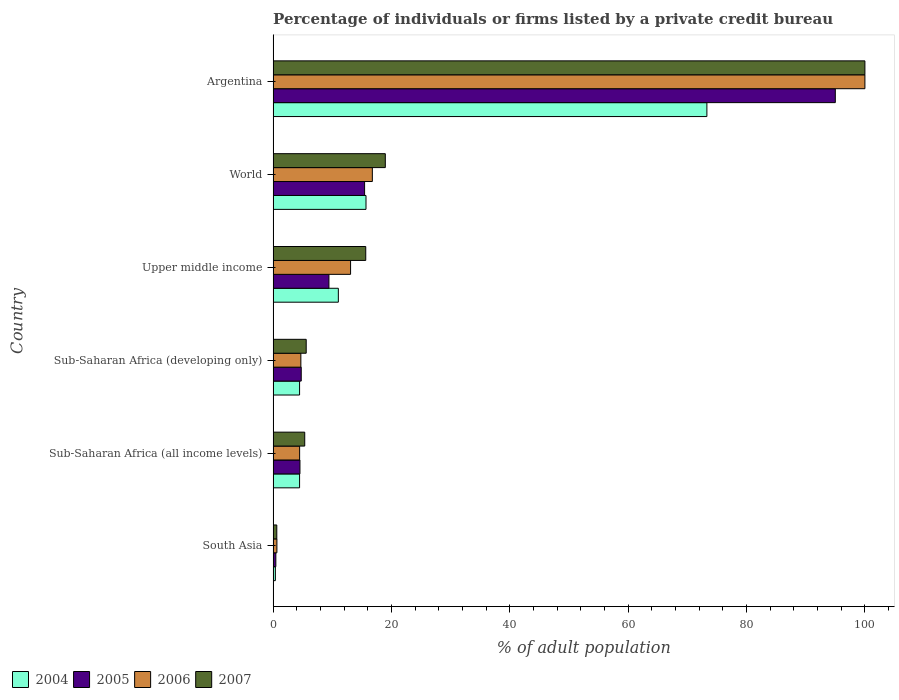How many different coloured bars are there?
Your response must be concise. 4. Are the number of bars per tick equal to the number of legend labels?
Make the answer very short. Yes. How many bars are there on the 5th tick from the bottom?
Provide a succinct answer. 4. What is the label of the 1st group of bars from the top?
Make the answer very short. Argentina. Across all countries, what is the minimum percentage of population listed by a private credit bureau in 2005?
Give a very brief answer. 0.46. In which country was the percentage of population listed by a private credit bureau in 2007 minimum?
Your response must be concise. South Asia. What is the total percentage of population listed by a private credit bureau in 2004 in the graph?
Make the answer very short. 109.34. What is the difference between the percentage of population listed by a private credit bureau in 2006 in Sub-Saharan Africa (developing only) and that in Upper middle income?
Offer a very short reply. -8.4. What is the difference between the percentage of population listed by a private credit bureau in 2007 in Sub-Saharan Africa (all income levels) and the percentage of population listed by a private credit bureau in 2005 in Upper middle income?
Give a very brief answer. -4.09. What is the average percentage of population listed by a private credit bureau in 2006 per country?
Offer a terse response. 23.28. What is the difference between the percentage of population listed by a private credit bureau in 2007 and percentage of population listed by a private credit bureau in 2005 in Sub-Saharan Africa (developing only)?
Make the answer very short. 0.84. In how many countries, is the percentage of population listed by a private credit bureau in 2005 greater than 100 %?
Your response must be concise. 0. What is the ratio of the percentage of population listed by a private credit bureau in 2004 in Sub-Saharan Africa (developing only) to that in Upper middle income?
Make the answer very short. 0.41. Is the percentage of population listed by a private credit bureau in 2007 in Upper middle income less than that in World?
Keep it short and to the point. Yes. Is the difference between the percentage of population listed by a private credit bureau in 2007 in Sub-Saharan Africa (all income levels) and Sub-Saharan Africa (developing only) greater than the difference between the percentage of population listed by a private credit bureau in 2005 in Sub-Saharan Africa (all income levels) and Sub-Saharan Africa (developing only)?
Your answer should be very brief. No. What is the difference between the highest and the second highest percentage of population listed by a private credit bureau in 2004?
Offer a terse response. 57.6. What is the difference between the highest and the lowest percentage of population listed by a private credit bureau in 2007?
Keep it short and to the point. 99.38. In how many countries, is the percentage of population listed by a private credit bureau in 2004 greater than the average percentage of population listed by a private credit bureau in 2004 taken over all countries?
Keep it short and to the point. 1. Is the sum of the percentage of population listed by a private credit bureau in 2007 in South Asia and Sub-Saharan Africa (developing only) greater than the maximum percentage of population listed by a private credit bureau in 2006 across all countries?
Your answer should be compact. No. Is it the case that in every country, the sum of the percentage of population listed by a private credit bureau in 2007 and percentage of population listed by a private credit bureau in 2006 is greater than the sum of percentage of population listed by a private credit bureau in 2004 and percentage of population listed by a private credit bureau in 2005?
Your answer should be very brief. No. What does the 4th bar from the bottom in Sub-Saharan Africa (all income levels) represents?
Your answer should be compact. 2007. Is it the case that in every country, the sum of the percentage of population listed by a private credit bureau in 2007 and percentage of population listed by a private credit bureau in 2006 is greater than the percentage of population listed by a private credit bureau in 2004?
Your answer should be very brief. Yes. How many bars are there?
Your answer should be compact. 24. What is the difference between two consecutive major ticks on the X-axis?
Your answer should be very brief. 20. Does the graph contain grids?
Give a very brief answer. No. Where does the legend appear in the graph?
Your response must be concise. Bottom left. How are the legend labels stacked?
Provide a short and direct response. Horizontal. What is the title of the graph?
Make the answer very short. Percentage of individuals or firms listed by a private credit bureau. Does "1969" appear as one of the legend labels in the graph?
Provide a succinct answer. No. What is the label or title of the X-axis?
Ensure brevity in your answer.  % of adult population. What is the label or title of the Y-axis?
Your answer should be very brief. Country. What is the % of adult population in 2004 in South Asia?
Make the answer very short. 0.38. What is the % of adult population in 2005 in South Asia?
Offer a terse response. 0.46. What is the % of adult population of 2006 in South Asia?
Provide a short and direct response. 0.64. What is the % of adult population of 2007 in South Asia?
Your response must be concise. 0.62. What is the % of adult population of 2004 in Sub-Saharan Africa (all income levels)?
Provide a succinct answer. 4.47. What is the % of adult population of 2005 in Sub-Saharan Africa (all income levels)?
Provide a short and direct response. 4.53. What is the % of adult population in 2006 in Sub-Saharan Africa (all income levels)?
Keep it short and to the point. 4.48. What is the % of adult population in 2007 in Sub-Saharan Africa (all income levels)?
Keep it short and to the point. 5.34. What is the % of adult population of 2004 in Sub-Saharan Africa (developing only)?
Your answer should be compact. 4.47. What is the % of adult population of 2005 in Sub-Saharan Africa (developing only)?
Provide a succinct answer. 4.75. What is the % of adult population in 2006 in Sub-Saharan Africa (developing only)?
Ensure brevity in your answer.  4.69. What is the % of adult population in 2007 in Sub-Saharan Africa (developing only)?
Offer a very short reply. 5.59. What is the % of adult population in 2004 in Upper middle income?
Offer a very short reply. 11.02. What is the % of adult population of 2005 in Upper middle income?
Give a very brief answer. 9.43. What is the % of adult population in 2006 in Upper middle income?
Ensure brevity in your answer.  13.09. What is the % of adult population of 2007 in Upper middle income?
Provide a succinct answer. 15.65. What is the % of adult population of 2004 in World?
Your answer should be compact. 15.7. What is the % of adult population in 2005 in World?
Your response must be concise. 15.46. What is the % of adult population in 2006 in World?
Provide a short and direct response. 16.77. What is the % of adult population of 2007 in World?
Your answer should be very brief. 18.96. What is the % of adult population in 2004 in Argentina?
Provide a succinct answer. 73.3. Across all countries, what is the maximum % of adult population in 2004?
Your answer should be compact. 73.3. Across all countries, what is the maximum % of adult population of 2005?
Ensure brevity in your answer.  95. Across all countries, what is the minimum % of adult population in 2004?
Give a very brief answer. 0.38. Across all countries, what is the minimum % of adult population of 2005?
Keep it short and to the point. 0.46. Across all countries, what is the minimum % of adult population in 2006?
Give a very brief answer. 0.64. Across all countries, what is the minimum % of adult population of 2007?
Your answer should be compact. 0.62. What is the total % of adult population of 2004 in the graph?
Provide a succinct answer. 109.34. What is the total % of adult population in 2005 in the graph?
Ensure brevity in your answer.  129.63. What is the total % of adult population of 2006 in the graph?
Provide a succinct answer. 139.66. What is the total % of adult population in 2007 in the graph?
Make the answer very short. 146.17. What is the difference between the % of adult population of 2004 in South Asia and that in Sub-Saharan Africa (all income levels)?
Make the answer very short. -4.09. What is the difference between the % of adult population in 2005 in South Asia and that in Sub-Saharan Africa (all income levels)?
Your answer should be very brief. -4.07. What is the difference between the % of adult population of 2006 in South Asia and that in Sub-Saharan Africa (all income levels)?
Give a very brief answer. -3.84. What is the difference between the % of adult population in 2007 in South Asia and that in Sub-Saharan Africa (all income levels)?
Your answer should be compact. -4.72. What is the difference between the % of adult population of 2004 in South Asia and that in Sub-Saharan Africa (developing only)?
Offer a terse response. -4.09. What is the difference between the % of adult population in 2005 in South Asia and that in Sub-Saharan Africa (developing only)?
Keep it short and to the point. -4.29. What is the difference between the % of adult population in 2006 in South Asia and that in Sub-Saharan Africa (developing only)?
Ensure brevity in your answer.  -4.05. What is the difference between the % of adult population of 2007 in South Asia and that in Sub-Saharan Africa (developing only)?
Give a very brief answer. -4.97. What is the difference between the % of adult population of 2004 in South Asia and that in Upper middle income?
Make the answer very short. -10.64. What is the difference between the % of adult population of 2005 in South Asia and that in Upper middle income?
Keep it short and to the point. -8.97. What is the difference between the % of adult population in 2006 in South Asia and that in Upper middle income?
Ensure brevity in your answer.  -12.45. What is the difference between the % of adult population in 2007 in South Asia and that in Upper middle income?
Offer a very short reply. -15.03. What is the difference between the % of adult population in 2004 in South Asia and that in World?
Your response must be concise. -15.32. What is the difference between the % of adult population in 2005 in South Asia and that in World?
Your answer should be very brief. -15. What is the difference between the % of adult population of 2006 in South Asia and that in World?
Keep it short and to the point. -16.13. What is the difference between the % of adult population of 2007 in South Asia and that in World?
Keep it short and to the point. -18.34. What is the difference between the % of adult population in 2004 in South Asia and that in Argentina?
Offer a terse response. -72.92. What is the difference between the % of adult population in 2005 in South Asia and that in Argentina?
Offer a very short reply. -94.54. What is the difference between the % of adult population of 2006 in South Asia and that in Argentina?
Your answer should be compact. -99.36. What is the difference between the % of adult population of 2007 in South Asia and that in Argentina?
Your answer should be compact. -99.38. What is the difference between the % of adult population of 2005 in Sub-Saharan Africa (all income levels) and that in Sub-Saharan Africa (developing only)?
Offer a terse response. -0.22. What is the difference between the % of adult population of 2006 in Sub-Saharan Africa (all income levels) and that in Sub-Saharan Africa (developing only)?
Your answer should be very brief. -0.21. What is the difference between the % of adult population of 2007 in Sub-Saharan Africa (all income levels) and that in Sub-Saharan Africa (developing only)?
Give a very brief answer. -0.25. What is the difference between the % of adult population in 2004 in Sub-Saharan Africa (all income levels) and that in Upper middle income?
Your response must be concise. -6.55. What is the difference between the % of adult population of 2005 in Sub-Saharan Africa (all income levels) and that in Upper middle income?
Your response must be concise. -4.9. What is the difference between the % of adult population of 2006 in Sub-Saharan Africa (all income levels) and that in Upper middle income?
Keep it short and to the point. -8.61. What is the difference between the % of adult population in 2007 in Sub-Saharan Africa (all income levels) and that in Upper middle income?
Give a very brief answer. -10.31. What is the difference between the % of adult population in 2004 in Sub-Saharan Africa (all income levels) and that in World?
Provide a short and direct response. -11.23. What is the difference between the % of adult population in 2005 in Sub-Saharan Africa (all income levels) and that in World?
Provide a succinct answer. -10.92. What is the difference between the % of adult population in 2006 in Sub-Saharan Africa (all income levels) and that in World?
Offer a terse response. -12.29. What is the difference between the % of adult population in 2007 in Sub-Saharan Africa (all income levels) and that in World?
Keep it short and to the point. -13.62. What is the difference between the % of adult population in 2004 in Sub-Saharan Africa (all income levels) and that in Argentina?
Offer a terse response. -68.83. What is the difference between the % of adult population in 2005 in Sub-Saharan Africa (all income levels) and that in Argentina?
Provide a succinct answer. -90.47. What is the difference between the % of adult population in 2006 in Sub-Saharan Africa (all income levels) and that in Argentina?
Give a very brief answer. -95.52. What is the difference between the % of adult population in 2007 in Sub-Saharan Africa (all income levels) and that in Argentina?
Provide a succinct answer. -94.66. What is the difference between the % of adult population of 2004 in Sub-Saharan Africa (developing only) and that in Upper middle income?
Give a very brief answer. -6.55. What is the difference between the % of adult population in 2005 in Sub-Saharan Africa (developing only) and that in Upper middle income?
Offer a very short reply. -4.68. What is the difference between the % of adult population of 2006 in Sub-Saharan Africa (developing only) and that in Upper middle income?
Your answer should be very brief. -8.4. What is the difference between the % of adult population in 2007 in Sub-Saharan Africa (developing only) and that in Upper middle income?
Offer a very short reply. -10.06. What is the difference between the % of adult population of 2004 in Sub-Saharan Africa (developing only) and that in World?
Your answer should be very brief. -11.23. What is the difference between the % of adult population of 2005 in Sub-Saharan Africa (developing only) and that in World?
Provide a succinct answer. -10.71. What is the difference between the % of adult population of 2006 in Sub-Saharan Africa (developing only) and that in World?
Give a very brief answer. -12.08. What is the difference between the % of adult population of 2007 in Sub-Saharan Africa (developing only) and that in World?
Your response must be concise. -13.37. What is the difference between the % of adult population in 2004 in Sub-Saharan Africa (developing only) and that in Argentina?
Make the answer very short. -68.83. What is the difference between the % of adult population in 2005 in Sub-Saharan Africa (developing only) and that in Argentina?
Keep it short and to the point. -90.25. What is the difference between the % of adult population in 2006 in Sub-Saharan Africa (developing only) and that in Argentina?
Ensure brevity in your answer.  -95.31. What is the difference between the % of adult population of 2007 in Sub-Saharan Africa (developing only) and that in Argentina?
Your answer should be very brief. -94.41. What is the difference between the % of adult population of 2004 in Upper middle income and that in World?
Offer a very short reply. -4.67. What is the difference between the % of adult population in 2005 in Upper middle income and that in World?
Ensure brevity in your answer.  -6.02. What is the difference between the % of adult population in 2006 in Upper middle income and that in World?
Your answer should be very brief. -3.68. What is the difference between the % of adult population of 2007 in Upper middle income and that in World?
Provide a succinct answer. -3.31. What is the difference between the % of adult population of 2004 in Upper middle income and that in Argentina?
Give a very brief answer. -62.28. What is the difference between the % of adult population of 2005 in Upper middle income and that in Argentina?
Keep it short and to the point. -85.57. What is the difference between the % of adult population in 2006 in Upper middle income and that in Argentina?
Give a very brief answer. -86.91. What is the difference between the % of adult population in 2007 in Upper middle income and that in Argentina?
Your answer should be compact. -84.35. What is the difference between the % of adult population of 2004 in World and that in Argentina?
Offer a terse response. -57.6. What is the difference between the % of adult population of 2005 in World and that in Argentina?
Make the answer very short. -79.54. What is the difference between the % of adult population in 2006 in World and that in Argentina?
Your answer should be very brief. -83.23. What is the difference between the % of adult population in 2007 in World and that in Argentina?
Give a very brief answer. -81.04. What is the difference between the % of adult population in 2004 in South Asia and the % of adult population in 2005 in Sub-Saharan Africa (all income levels)?
Your answer should be compact. -4.15. What is the difference between the % of adult population in 2004 in South Asia and the % of adult population in 2006 in Sub-Saharan Africa (all income levels)?
Give a very brief answer. -4.1. What is the difference between the % of adult population of 2004 in South Asia and the % of adult population of 2007 in Sub-Saharan Africa (all income levels)?
Provide a short and direct response. -4.96. What is the difference between the % of adult population of 2005 in South Asia and the % of adult population of 2006 in Sub-Saharan Africa (all income levels)?
Your response must be concise. -4.02. What is the difference between the % of adult population of 2005 in South Asia and the % of adult population of 2007 in Sub-Saharan Africa (all income levels)?
Keep it short and to the point. -4.88. What is the difference between the % of adult population in 2006 in South Asia and the % of adult population in 2007 in Sub-Saharan Africa (all income levels)?
Ensure brevity in your answer.  -4.7. What is the difference between the % of adult population of 2004 in South Asia and the % of adult population of 2005 in Sub-Saharan Africa (developing only)?
Provide a succinct answer. -4.37. What is the difference between the % of adult population in 2004 in South Asia and the % of adult population in 2006 in Sub-Saharan Africa (developing only)?
Offer a very short reply. -4.31. What is the difference between the % of adult population in 2004 in South Asia and the % of adult population in 2007 in Sub-Saharan Africa (developing only)?
Offer a terse response. -5.21. What is the difference between the % of adult population in 2005 in South Asia and the % of adult population in 2006 in Sub-Saharan Africa (developing only)?
Make the answer very short. -4.23. What is the difference between the % of adult population in 2005 in South Asia and the % of adult population in 2007 in Sub-Saharan Africa (developing only)?
Keep it short and to the point. -5.13. What is the difference between the % of adult population of 2006 in South Asia and the % of adult population of 2007 in Sub-Saharan Africa (developing only)?
Provide a succinct answer. -4.95. What is the difference between the % of adult population in 2004 in South Asia and the % of adult population in 2005 in Upper middle income?
Give a very brief answer. -9.05. What is the difference between the % of adult population of 2004 in South Asia and the % of adult population of 2006 in Upper middle income?
Keep it short and to the point. -12.71. What is the difference between the % of adult population in 2004 in South Asia and the % of adult population in 2007 in Upper middle income?
Offer a very short reply. -15.27. What is the difference between the % of adult population of 2005 in South Asia and the % of adult population of 2006 in Upper middle income?
Keep it short and to the point. -12.63. What is the difference between the % of adult population of 2005 in South Asia and the % of adult population of 2007 in Upper middle income?
Provide a succinct answer. -15.19. What is the difference between the % of adult population of 2006 in South Asia and the % of adult population of 2007 in Upper middle income?
Give a very brief answer. -15.01. What is the difference between the % of adult population in 2004 in South Asia and the % of adult population in 2005 in World?
Offer a very short reply. -15.08. What is the difference between the % of adult population in 2004 in South Asia and the % of adult population in 2006 in World?
Make the answer very short. -16.39. What is the difference between the % of adult population in 2004 in South Asia and the % of adult population in 2007 in World?
Your response must be concise. -18.58. What is the difference between the % of adult population of 2005 in South Asia and the % of adult population of 2006 in World?
Offer a very short reply. -16.31. What is the difference between the % of adult population in 2005 in South Asia and the % of adult population in 2007 in World?
Your answer should be very brief. -18.5. What is the difference between the % of adult population of 2006 in South Asia and the % of adult population of 2007 in World?
Ensure brevity in your answer.  -18.32. What is the difference between the % of adult population in 2004 in South Asia and the % of adult population in 2005 in Argentina?
Your answer should be compact. -94.62. What is the difference between the % of adult population of 2004 in South Asia and the % of adult population of 2006 in Argentina?
Make the answer very short. -99.62. What is the difference between the % of adult population in 2004 in South Asia and the % of adult population in 2007 in Argentina?
Your response must be concise. -99.62. What is the difference between the % of adult population in 2005 in South Asia and the % of adult population in 2006 in Argentina?
Give a very brief answer. -99.54. What is the difference between the % of adult population in 2005 in South Asia and the % of adult population in 2007 in Argentina?
Offer a terse response. -99.54. What is the difference between the % of adult population in 2006 in South Asia and the % of adult population in 2007 in Argentina?
Your answer should be very brief. -99.36. What is the difference between the % of adult population of 2004 in Sub-Saharan Africa (all income levels) and the % of adult population of 2005 in Sub-Saharan Africa (developing only)?
Provide a succinct answer. -0.28. What is the difference between the % of adult population of 2004 in Sub-Saharan Africa (all income levels) and the % of adult population of 2006 in Sub-Saharan Africa (developing only)?
Your answer should be compact. -0.22. What is the difference between the % of adult population of 2004 in Sub-Saharan Africa (all income levels) and the % of adult population of 2007 in Sub-Saharan Africa (developing only)?
Your answer should be very brief. -1.12. What is the difference between the % of adult population of 2005 in Sub-Saharan Africa (all income levels) and the % of adult population of 2006 in Sub-Saharan Africa (developing only)?
Ensure brevity in your answer.  -0.15. What is the difference between the % of adult population of 2005 in Sub-Saharan Africa (all income levels) and the % of adult population of 2007 in Sub-Saharan Africa (developing only)?
Provide a succinct answer. -1.06. What is the difference between the % of adult population in 2006 in Sub-Saharan Africa (all income levels) and the % of adult population in 2007 in Sub-Saharan Africa (developing only)?
Your response must be concise. -1.11. What is the difference between the % of adult population of 2004 in Sub-Saharan Africa (all income levels) and the % of adult population of 2005 in Upper middle income?
Give a very brief answer. -4.96. What is the difference between the % of adult population in 2004 in Sub-Saharan Africa (all income levels) and the % of adult population in 2006 in Upper middle income?
Your answer should be very brief. -8.62. What is the difference between the % of adult population in 2004 in Sub-Saharan Africa (all income levels) and the % of adult population in 2007 in Upper middle income?
Offer a very short reply. -11.18. What is the difference between the % of adult population in 2005 in Sub-Saharan Africa (all income levels) and the % of adult population in 2006 in Upper middle income?
Your response must be concise. -8.55. What is the difference between the % of adult population in 2005 in Sub-Saharan Africa (all income levels) and the % of adult population in 2007 in Upper middle income?
Provide a succinct answer. -11.12. What is the difference between the % of adult population in 2006 in Sub-Saharan Africa (all income levels) and the % of adult population in 2007 in Upper middle income?
Make the answer very short. -11.18. What is the difference between the % of adult population in 2004 in Sub-Saharan Africa (all income levels) and the % of adult population in 2005 in World?
Your response must be concise. -10.99. What is the difference between the % of adult population of 2004 in Sub-Saharan Africa (all income levels) and the % of adult population of 2006 in World?
Provide a short and direct response. -12.3. What is the difference between the % of adult population in 2004 in Sub-Saharan Africa (all income levels) and the % of adult population in 2007 in World?
Give a very brief answer. -14.49. What is the difference between the % of adult population in 2005 in Sub-Saharan Africa (all income levels) and the % of adult population in 2006 in World?
Keep it short and to the point. -12.23. What is the difference between the % of adult population of 2005 in Sub-Saharan Africa (all income levels) and the % of adult population of 2007 in World?
Your answer should be very brief. -14.43. What is the difference between the % of adult population of 2006 in Sub-Saharan Africa (all income levels) and the % of adult population of 2007 in World?
Give a very brief answer. -14.48. What is the difference between the % of adult population in 2004 in Sub-Saharan Africa (all income levels) and the % of adult population in 2005 in Argentina?
Keep it short and to the point. -90.53. What is the difference between the % of adult population of 2004 in Sub-Saharan Africa (all income levels) and the % of adult population of 2006 in Argentina?
Ensure brevity in your answer.  -95.53. What is the difference between the % of adult population of 2004 in Sub-Saharan Africa (all income levels) and the % of adult population of 2007 in Argentina?
Provide a short and direct response. -95.53. What is the difference between the % of adult population in 2005 in Sub-Saharan Africa (all income levels) and the % of adult population in 2006 in Argentina?
Provide a succinct answer. -95.47. What is the difference between the % of adult population in 2005 in Sub-Saharan Africa (all income levels) and the % of adult population in 2007 in Argentina?
Provide a short and direct response. -95.47. What is the difference between the % of adult population of 2006 in Sub-Saharan Africa (all income levels) and the % of adult population of 2007 in Argentina?
Offer a terse response. -95.52. What is the difference between the % of adult population in 2004 in Sub-Saharan Africa (developing only) and the % of adult population in 2005 in Upper middle income?
Your answer should be compact. -4.96. What is the difference between the % of adult population in 2004 in Sub-Saharan Africa (developing only) and the % of adult population in 2006 in Upper middle income?
Make the answer very short. -8.62. What is the difference between the % of adult population in 2004 in Sub-Saharan Africa (developing only) and the % of adult population in 2007 in Upper middle income?
Offer a terse response. -11.18. What is the difference between the % of adult population of 2005 in Sub-Saharan Africa (developing only) and the % of adult population of 2006 in Upper middle income?
Offer a terse response. -8.34. What is the difference between the % of adult population in 2005 in Sub-Saharan Africa (developing only) and the % of adult population in 2007 in Upper middle income?
Keep it short and to the point. -10.9. What is the difference between the % of adult population in 2006 in Sub-Saharan Africa (developing only) and the % of adult population in 2007 in Upper middle income?
Ensure brevity in your answer.  -10.97. What is the difference between the % of adult population of 2004 in Sub-Saharan Africa (developing only) and the % of adult population of 2005 in World?
Provide a short and direct response. -10.99. What is the difference between the % of adult population in 2004 in Sub-Saharan Africa (developing only) and the % of adult population in 2006 in World?
Your response must be concise. -12.3. What is the difference between the % of adult population in 2004 in Sub-Saharan Africa (developing only) and the % of adult population in 2007 in World?
Make the answer very short. -14.49. What is the difference between the % of adult population in 2005 in Sub-Saharan Africa (developing only) and the % of adult population in 2006 in World?
Your answer should be compact. -12.02. What is the difference between the % of adult population in 2005 in Sub-Saharan Africa (developing only) and the % of adult population in 2007 in World?
Ensure brevity in your answer.  -14.21. What is the difference between the % of adult population of 2006 in Sub-Saharan Africa (developing only) and the % of adult population of 2007 in World?
Provide a short and direct response. -14.27. What is the difference between the % of adult population of 2004 in Sub-Saharan Africa (developing only) and the % of adult population of 2005 in Argentina?
Ensure brevity in your answer.  -90.53. What is the difference between the % of adult population of 2004 in Sub-Saharan Africa (developing only) and the % of adult population of 2006 in Argentina?
Keep it short and to the point. -95.53. What is the difference between the % of adult population in 2004 in Sub-Saharan Africa (developing only) and the % of adult population in 2007 in Argentina?
Provide a succinct answer. -95.53. What is the difference between the % of adult population in 2005 in Sub-Saharan Africa (developing only) and the % of adult population in 2006 in Argentina?
Your response must be concise. -95.25. What is the difference between the % of adult population in 2005 in Sub-Saharan Africa (developing only) and the % of adult population in 2007 in Argentina?
Your answer should be compact. -95.25. What is the difference between the % of adult population in 2006 in Sub-Saharan Africa (developing only) and the % of adult population in 2007 in Argentina?
Give a very brief answer. -95.31. What is the difference between the % of adult population in 2004 in Upper middle income and the % of adult population in 2005 in World?
Give a very brief answer. -4.43. What is the difference between the % of adult population in 2004 in Upper middle income and the % of adult population in 2006 in World?
Make the answer very short. -5.74. What is the difference between the % of adult population of 2004 in Upper middle income and the % of adult population of 2007 in World?
Your answer should be compact. -7.94. What is the difference between the % of adult population of 2005 in Upper middle income and the % of adult population of 2006 in World?
Offer a very short reply. -7.33. What is the difference between the % of adult population in 2005 in Upper middle income and the % of adult population in 2007 in World?
Keep it short and to the point. -9.53. What is the difference between the % of adult population in 2006 in Upper middle income and the % of adult population in 2007 in World?
Ensure brevity in your answer.  -5.87. What is the difference between the % of adult population of 2004 in Upper middle income and the % of adult population of 2005 in Argentina?
Keep it short and to the point. -83.98. What is the difference between the % of adult population of 2004 in Upper middle income and the % of adult population of 2006 in Argentina?
Keep it short and to the point. -88.98. What is the difference between the % of adult population in 2004 in Upper middle income and the % of adult population in 2007 in Argentina?
Your response must be concise. -88.98. What is the difference between the % of adult population of 2005 in Upper middle income and the % of adult population of 2006 in Argentina?
Your answer should be very brief. -90.57. What is the difference between the % of adult population in 2005 in Upper middle income and the % of adult population in 2007 in Argentina?
Give a very brief answer. -90.57. What is the difference between the % of adult population in 2006 in Upper middle income and the % of adult population in 2007 in Argentina?
Make the answer very short. -86.91. What is the difference between the % of adult population of 2004 in World and the % of adult population of 2005 in Argentina?
Your answer should be very brief. -79.3. What is the difference between the % of adult population of 2004 in World and the % of adult population of 2006 in Argentina?
Provide a short and direct response. -84.3. What is the difference between the % of adult population in 2004 in World and the % of adult population in 2007 in Argentina?
Keep it short and to the point. -84.3. What is the difference between the % of adult population in 2005 in World and the % of adult population in 2006 in Argentina?
Provide a short and direct response. -84.54. What is the difference between the % of adult population in 2005 in World and the % of adult population in 2007 in Argentina?
Offer a very short reply. -84.54. What is the difference between the % of adult population in 2006 in World and the % of adult population in 2007 in Argentina?
Your answer should be very brief. -83.23. What is the average % of adult population in 2004 per country?
Your response must be concise. 18.22. What is the average % of adult population in 2005 per country?
Ensure brevity in your answer.  21.61. What is the average % of adult population in 2006 per country?
Offer a very short reply. 23.28. What is the average % of adult population in 2007 per country?
Offer a very short reply. 24.36. What is the difference between the % of adult population of 2004 and % of adult population of 2005 in South Asia?
Make the answer very short. -0.08. What is the difference between the % of adult population in 2004 and % of adult population in 2006 in South Asia?
Ensure brevity in your answer.  -0.26. What is the difference between the % of adult population of 2004 and % of adult population of 2007 in South Asia?
Your answer should be compact. -0.24. What is the difference between the % of adult population in 2005 and % of adult population in 2006 in South Asia?
Your answer should be very brief. -0.18. What is the difference between the % of adult population of 2005 and % of adult population of 2007 in South Asia?
Make the answer very short. -0.16. What is the difference between the % of adult population of 2006 and % of adult population of 2007 in South Asia?
Give a very brief answer. 0.02. What is the difference between the % of adult population in 2004 and % of adult population in 2005 in Sub-Saharan Africa (all income levels)?
Give a very brief answer. -0.06. What is the difference between the % of adult population in 2004 and % of adult population in 2006 in Sub-Saharan Africa (all income levels)?
Give a very brief answer. -0.01. What is the difference between the % of adult population of 2004 and % of adult population of 2007 in Sub-Saharan Africa (all income levels)?
Make the answer very short. -0.87. What is the difference between the % of adult population of 2005 and % of adult population of 2006 in Sub-Saharan Africa (all income levels)?
Give a very brief answer. 0.06. What is the difference between the % of adult population in 2005 and % of adult population in 2007 in Sub-Saharan Africa (all income levels)?
Make the answer very short. -0.81. What is the difference between the % of adult population in 2006 and % of adult population in 2007 in Sub-Saharan Africa (all income levels)?
Your answer should be compact. -0.86. What is the difference between the % of adult population in 2004 and % of adult population in 2005 in Sub-Saharan Africa (developing only)?
Your answer should be very brief. -0.28. What is the difference between the % of adult population in 2004 and % of adult population in 2006 in Sub-Saharan Africa (developing only)?
Make the answer very short. -0.22. What is the difference between the % of adult population in 2004 and % of adult population in 2007 in Sub-Saharan Africa (developing only)?
Give a very brief answer. -1.12. What is the difference between the % of adult population of 2005 and % of adult population of 2006 in Sub-Saharan Africa (developing only)?
Your answer should be very brief. 0.06. What is the difference between the % of adult population in 2005 and % of adult population in 2007 in Sub-Saharan Africa (developing only)?
Your answer should be compact. -0.84. What is the difference between the % of adult population of 2006 and % of adult population of 2007 in Sub-Saharan Africa (developing only)?
Offer a very short reply. -0.9. What is the difference between the % of adult population of 2004 and % of adult population of 2005 in Upper middle income?
Provide a short and direct response. 1.59. What is the difference between the % of adult population in 2004 and % of adult population in 2006 in Upper middle income?
Offer a terse response. -2.07. What is the difference between the % of adult population of 2004 and % of adult population of 2007 in Upper middle income?
Offer a terse response. -4.63. What is the difference between the % of adult population in 2005 and % of adult population in 2006 in Upper middle income?
Ensure brevity in your answer.  -3.66. What is the difference between the % of adult population of 2005 and % of adult population of 2007 in Upper middle income?
Provide a short and direct response. -6.22. What is the difference between the % of adult population in 2006 and % of adult population in 2007 in Upper middle income?
Make the answer very short. -2.56. What is the difference between the % of adult population in 2004 and % of adult population in 2005 in World?
Offer a terse response. 0.24. What is the difference between the % of adult population of 2004 and % of adult population of 2006 in World?
Keep it short and to the point. -1.07. What is the difference between the % of adult population of 2004 and % of adult population of 2007 in World?
Give a very brief answer. -3.26. What is the difference between the % of adult population in 2005 and % of adult population in 2006 in World?
Ensure brevity in your answer.  -1.31. What is the difference between the % of adult population in 2005 and % of adult population in 2007 in World?
Give a very brief answer. -3.5. What is the difference between the % of adult population of 2006 and % of adult population of 2007 in World?
Your answer should be very brief. -2.19. What is the difference between the % of adult population of 2004 and % of adult population of 2005 in Argentina?
Offer a very short reply. -21.7. What is the difference between the % of adult population in 2004 and % of adult population in 2006 in Argentina?
Make the answer very short. -26.7. What is the difference between the % of adult population in 2004 and % of adult population in 2007 in Argentina?
Ensure brevity in your answer.  -26.7. What is the difference between the % of adult population of 2005 and % of adult population of 2006 in Argentina?
Your answer should be compact. -5. What is the difference between the % of adult population of 2005 and % of adult population of 2007 in Argentina?
Offer a terse response. -5. What is the ratio of the % of adult population in 2004 in South Asia to that in Sub-Saharan Africa (all income levels)?
Keep it short and to the point. 0.09. What is the ratio of the % of adult population of 2005 in South Asia to that in Sub-Saharan Africa (all income levels)?
Offer a terse response. 0.1. What is the ratio of the % of adult population in 2006 in South Asia to that in Sub-Saharan Africa (all income levels)?
Your answer should be compact. 0.14. What is the ratio of the % of adult population in 2007 in South Asia to that in Sub-Saharan Africa (all income levels)?
Your response must be concise. 0.12. What is the ratio of the % of adult population in 2004 in South Asia to that in Sub-Saharan Africa (developing only)?
Provide a short and direct response. 0.09. What is the ratio of the % of adult population of 2005 in South Asia to that in Sub-Saharan Africa (developing only)?
Make the answer very short. 0.1. What is the ratio of the % of adult population of 2006 in South Asia to that in Sub-Saharan Africa (developing only)?
Offer a very short reply. 0.14. What is the ratio of the % of adult population of 2007 in South Asia to that in Sub-Saharan Africa (developing only)?
Ensure brevity in your answer.  0.11. What is the ratio of the % of adult population of 2004 in South Asia to that in Upper middle income?
Offer a very short reply. 0.03. What is the ratio of the % of adult population of 2005 in South Asia to that in Upper middle income?
Provide a short and direct response. 0.05. What is the ratio of the % of adult population in 2006 in South Asia to that in Upper middle income?
Your response must be concise. 0.05. What is the ratio of the % of adult population in 2007 in South Asia to that in Upper middle income?
Your answer should be compact. 0.04. What is the ratio of the % of adult population in 2004 in South Asia to that in World?
Your answer should be compact. 0.02. What is the ratio of the % of adult population of 2005 in South Asia to that in World?
Offer a very short reply. 0.03. What is the ratio of the % of adult population in 2006 in South Asia to that in World?
Your response must be concise. 0.04. What is the ratio of the % of adult population of 2007 in South Asia to that in World?
Offer a very short reply. 0.03. What is the ratio of the % of adult population in 2004 in South Asia to that in Argentina?
Provide a short and direct response. 0.01. What is the ratio of the % of adult population in 2005 in South Asia to that in Argentina?
Ensure brevity in your answer.  0. What is the ratio of the % of adult population of 2006 in South Asia to that in Argentina?
Your answer should be compact. 0.01. What is the ratio of the % of adult population of 2007 in South Asia to that in Argentina?
Your response must be concise. 0.01. What is the ratio of the % of adult population of 2004 in Sub-Saharan Africa (all income levels) to that in Sub-Saharan Africa (developing only)?
Provide a short and direct response. 1. What is the ratio of the % of adult population in 2005 in Sub-Saharan Africa (all income levels) to that in Sub-Saharan Africa (developing only)?
Give a very brief answer. 0.95. What is the ratio of the % of adult population of 2006 in Sub-Saharan Africa (all income levels) to that in Sub-Saharan Africa (developing only)?
Offer a very short reply. 0.96. What is the ratio of the % of adult population of 2007 in Sub-Saharan Africa (all income levels) to that in Sub-Saharan Africa (developing only)?
Give a very brief answer. 0.96. What is the ratio of the % of adult population in 2004 in Sub-Saharan Africa (all income levels) to that in Upper middle income?
Keep it short and to the point. 0.41. What is the ratio of the % of adult population of 2005 in Sub-Saharan Africa (all income levels) to that in Upper middle income?
Make the answer very short. 0.48. What is the ratio of the % of adult population of 2006 in Sub-Saharan Africa (all income levels) to that in Upper middle income?
Ensure brevity in your answer.  0.34. What is the ratio of the % of adult population in 2007 in Sub-Saharan Africa (all income levels) to that in Upper middle income?
Provide a succinct answer. 0.34. What is the ratio of the % of adult population in 2004 in Sub-Saharan Africa (all income levels) to that in World?
Provide a short and direct response. 0.28. What is the ratio of the % of adult population of 2005 in Sub-Saharan Africa (all income levels) to that in World?
Offer a terse response. 0.29. What is the ratio of the % of adult population of 2006 in Sub-Saharan Africa (all income levels) to that in World?
Your response must be concise. 0.27. What is the ratio of the % of adult population of 2007 in Sub-Saharan Africa (all income levels) to that in World?
Offer a very short reply. 0.28. What is the ratio of the % of adult population in 2004 in Sub-Saharan Africa (all income levels) to that in Argentina?
Make the answer very short. 0.06. What is the ratio of the % of adult population in 2005 in Sub-Saharan Africa (all income levels) to that in Argentina?
Offer a terse response. 0.05. What is the ratio of the % of adult population of 2006 in Sub-Saharan Africa (all income levels) to that in Argentina?
Your answer should be very brief. 0.04. What is the ratio of the % of adult population in 2007 in Sub-Saharan Africa (all income levels) to that in Argentina?
Your answer should be compact. 0.05. What is the ratio of the % of adult population of 2004 in Sub-Saharan Africa (developing only) to that in Upper middle income?
Keep it short and to the point. 0.41. What is the ratio of the % of adult population of 2005 in Sub-Saharan Africa (developing only) to that in Upper middle income?
Ensure brevity in your answer.  0.5. What is the ratio of the % of adult population of 2006 in Sub-Saharan Africa (developing only) to that in Upper middle income?
Keep it short and to the point. 0.36. What is the ratio of the % of adult population in 2007 in Sub-Saharan Africa (developing only) to that in Upper middle income?
Provide a short and direct response. 0.36. What is the ratio of the % of adult population in 2004 in Sub-Saharan Africa (developing only) to that in World?
Give a very brief answer. 0.28. What is the ratio of the % of adult population of 2005 in Sub-Saharan Africa (developing only) to that in World?
Your answer should be compact. 0.31. What is the ratio of the % of adult population in 2006 in Sub-Saharan Africa (developing only) to that in World?
Offer a terse response. 0.28. What is the ratio of the % of adult population of 2007 in Sub-Saharan Africa (developing only) to that in World?
Your answer should be very brief. 0.29. What is the ratio of the % of adult population in 2004 in Sub-Saharan Africa (developing only) to that in Argentina?
Keep it short and to the point. 0.06. What is the ratio of the % of adult population in 2005 in Sub-Saharan Africa (developing only) to that in Argentina?
Your response must be concise. 0.05. What is the ratio of the % of adult population of 2006 in Sub-Saharan Africa (developing only) to that in Argentina?
Offer a very short reply. 0.05. What is the ratio of the % of adult population in 2007 in Sub-Saharan Africa (developing only) to that in Argentina?
Make the answer very short. 0.06. What is the ratio of the % of adult population in 2004 in Upper middle income to that in World?
Provide a succinct answer. 0.7. What is the ratio of the % of adult population of 2005 in Upper middle income to that in World?
Offer a terse response. 0.61. What is the ratio of the % of adult population in 2006 in Upper middle income to that in World?
Ensure brevity in your answer.  0.78. What is the ratio of the % of adult population of 2007 in Upper middle income to that in World?
Offer a terse response. 0.83. What is the ratio of the % of adult population in 2004 in Upper middle income to that in Argentina?
Make the answer very short. 0.15. What is the ratio of the % of adult population of 2005 in Upper middle income to that in Argentina?
Your answer should be very brief. 0.1. What is the ratio of the % of adult population in 2006 in Upper middle income to that in Argentina?
Offer a very short reply. 0.13. What is the ratio of the % of adult population of 2007 in Upper middle income to that in Argentina?
Provide a short and direct response. 0.16. What is the ratio of the % of adult population in 2004 in World to that in Argentina?
Make the answer very short. 0.21. What is the ratio of the % of adult population in 2005 in World to that in Argentina?
Keep it short and to the point. 0.16. What is the ratio of the % of adult population in 2006 in World to that in Argentina?
Your response must be concise. 0.17. What is the ratio of the % of adult population of 2007 in World to that in Argentina?
Offer a terse response. 0.19. What is the difference between the highest and the second highest % of adult population in 2004?
Make the answer very short. 57.6. What is the difference between the highest and the second highest % of adult population of 2005?
Give a very brief answer. 79.54. What is the difference between the highest and the second highest % of adult population in 2006?
Offer a terse response. 83.23. What is the difference between the highest and the second highest % of adult population in 2007?
Give a very brief answer. 81.04. What is the difference between the highest and the lowest % of adult population in 2004?
Keep it short and to the point. 72.92. What is the difference between the highest and the lowest % of adult population in 2005?
Make the answer very short. 94.54. What is the difference between the highest and the lowest % of adult population in 2006?
Your answer should be very brief. 99.36. What is the difference between the highest and the lowest % of adult population in 2007?
Ensure brevity in your answer.  99.38. 